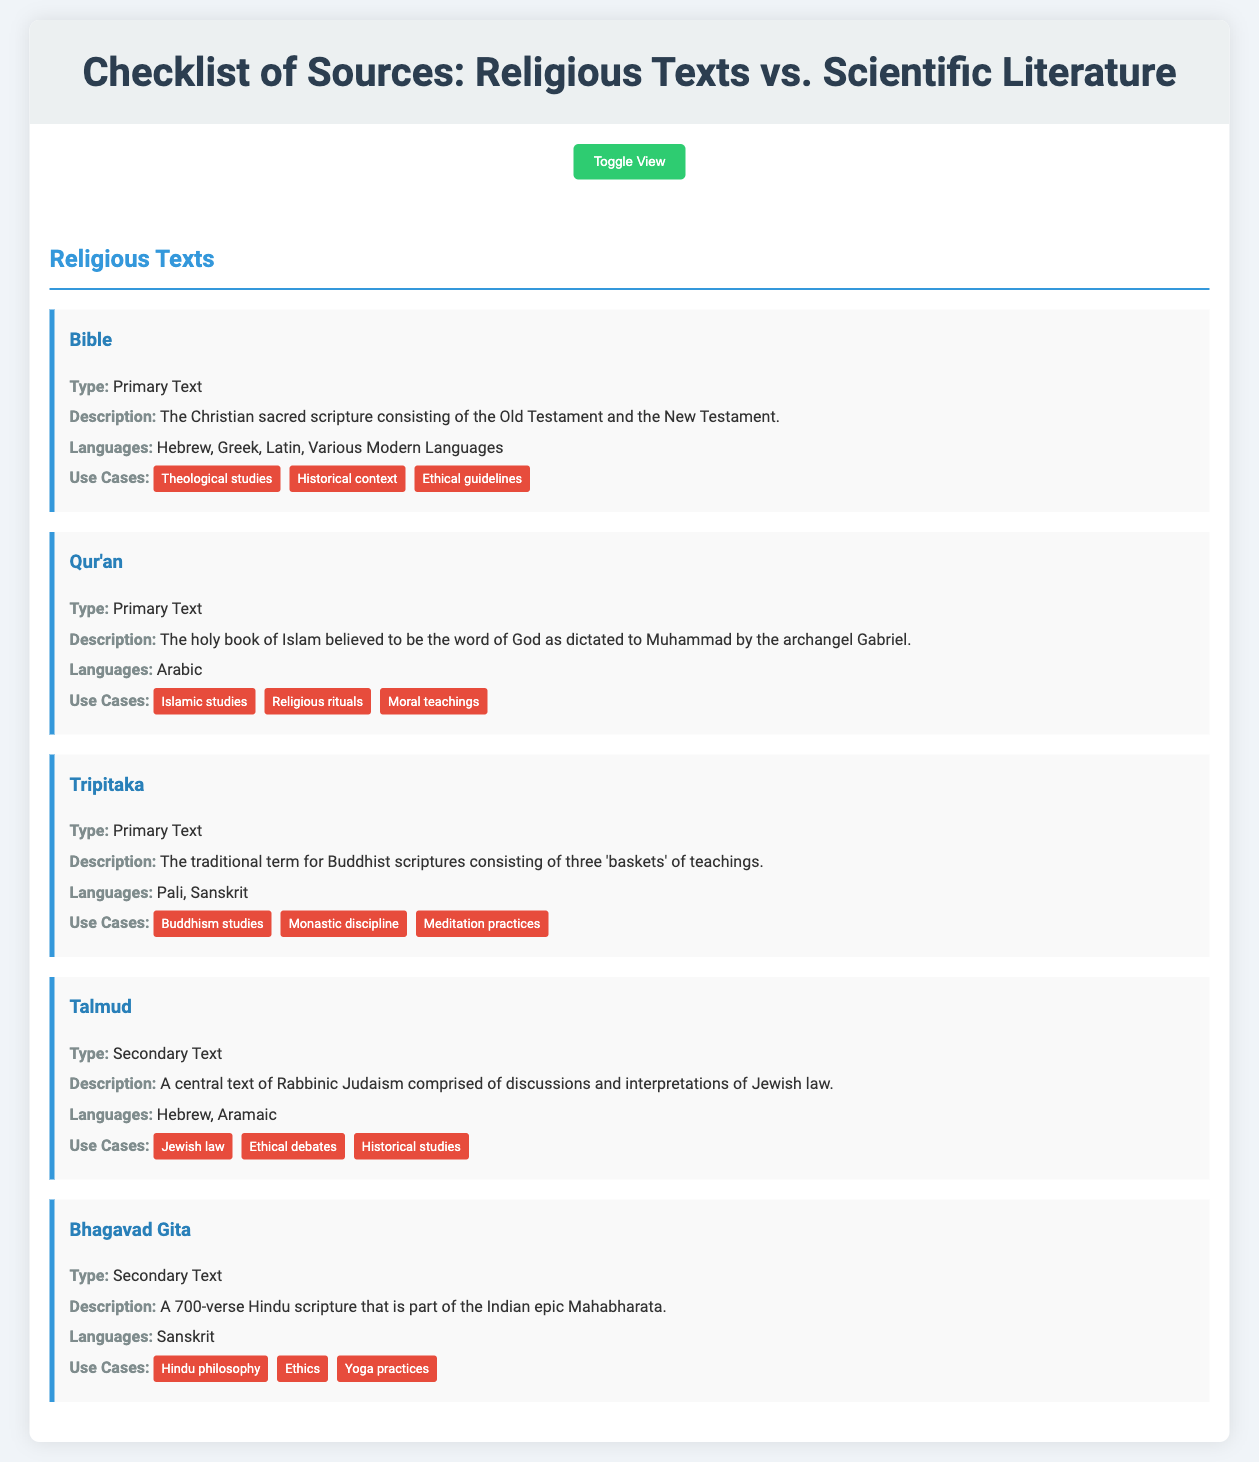what is the primary text of Christianity? The document lists the Bible as the primary text of Christianity.
Answer: Bible what language is the Qur'an primarily written in? The document indicates that the Qur'an is written in Arabic.
Answer: Arabic which scientific journal publishes cutting-edge research across a wide range of disciplines? The document identifies "Science" as the journal that publishes such research.
Answer: Science what type of document is the IPCC Reports categorized as? According to the document, the IPCC Reports are classified as a white paper.
Answer: White Paper what is a use case for the Bhagavad Gita? The document lists Hindu philosophy as one of the use cases for the Bhagavad Gita.
Answer: Hindu philosophy how many 'baskets' of teachings does the Tripitaka consist of? The document mentions that the Tripitaka consists of three 'baskets' of teachings.
Answer: Three what type of literature is "Nature"? The document specifies that "Nature" is an empirical study.
Answer: Empirical Study what is the purpose of the Talmud? The document states that the Talmud is used for discussions and interpretations of Jewish law.
Answer: Discussions and interpretations of Jewish law which source is primarily written in Pali and Sanskrit? The document indicates that the Tripitaka is written in Pali and Sanskrit.
Answer: Tripitaka 